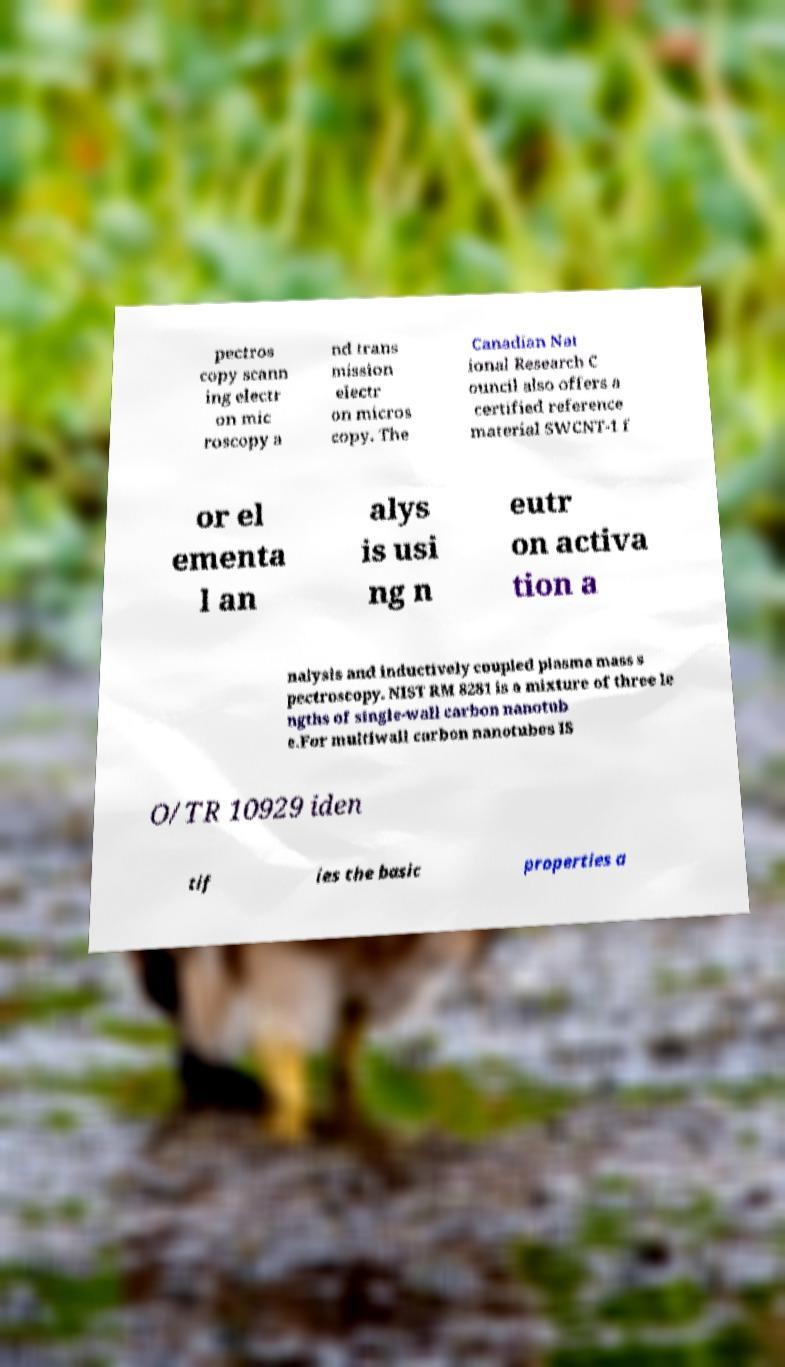What messages or text are displayed in this image? I need them in a readable, typed format. pectros copy scann ing electr on mic roscopy a nd trans mission electr on micros copy. The Canadian Nat ional Research C ouncil also offers a certified reference material SWCNT-1 f or el ementa l an alys is usi ng n eutr on activa tion a nalysis and inductively coupled plasma mass s pectroscopy. NIST RM 8281 is a mixture of three le ngths of single-wall carbon nanotub e.For multiwall carbon nanotubes IS O/TR 10929 iden tif ies the basic properties a 